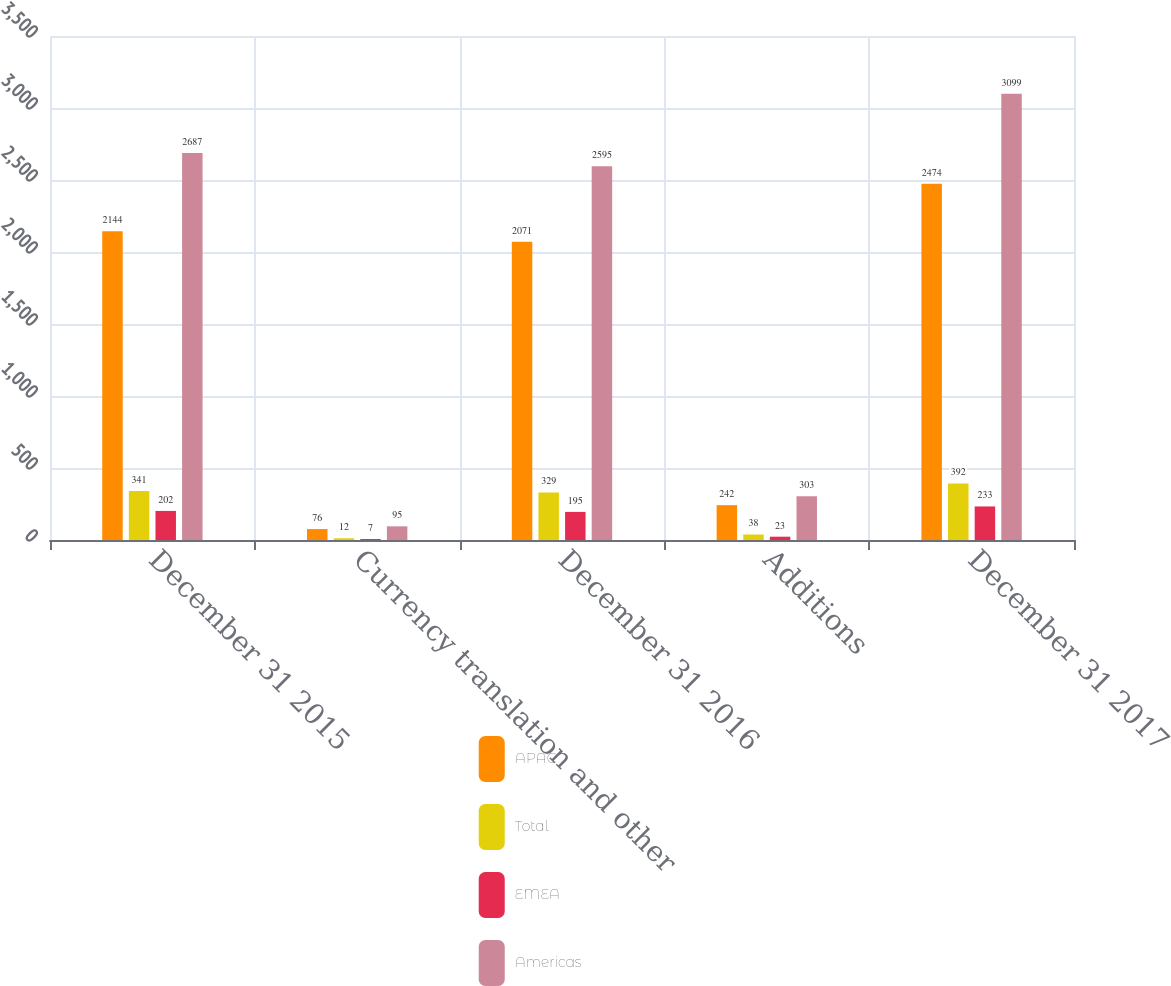Convert chart. <chart><loc_0><loc_0><loc_500><loc_500><stacked_bar_chart><ecel><fcel>December 31 2015<fcel>Currency translation and other<fcel>December 31 2016<fcel>Additions<fcel>December 31 2017<nl><fcel>APAC<fcel>2144<fcel>76<fcel>2071<fcel>242<fcel>2474<nl><fcel>Total<fcel>341<fcel>12<fcel>329<fcel>38<fcel>392<nl><fcel>EMEA<fcel>202<fcel>7<fcel>195<fcel>23<fcel>233<nl><fcel>Americas<fcel>2687<fcel>95<fcel>2595<fcel>303<fcel>3099<nl></chart> 